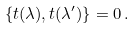Convert formula to latex. <formula><loc_0><loc_0><loc_500><loc_500>\{ { t } ( \lambda ) , { t } ( \lambda ^ { \prime } ) \} = 0 \, .</formula> 